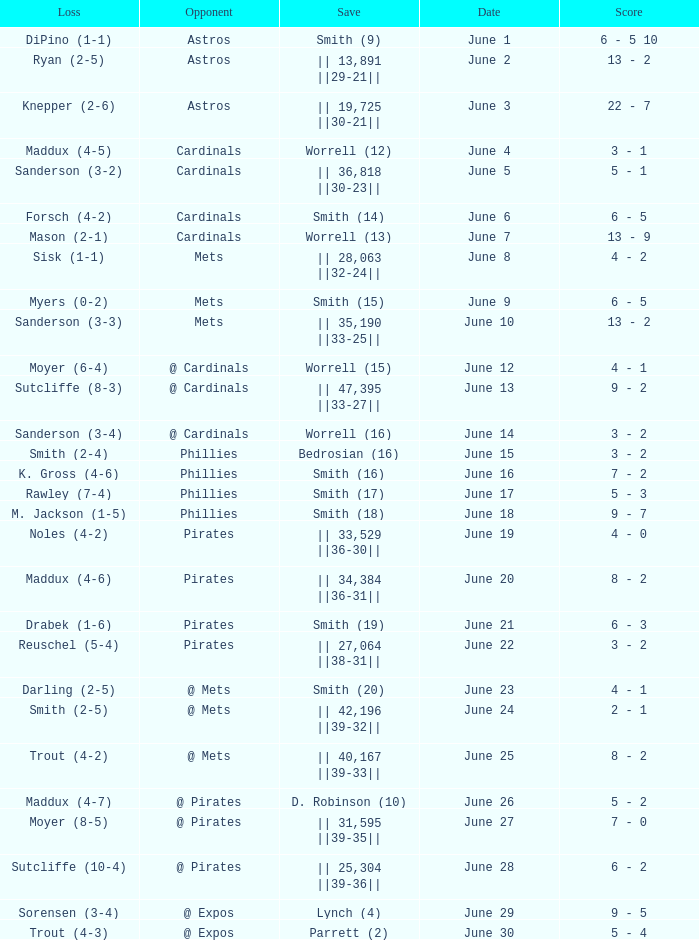What is the date for the game that included a loss of sutcliffe (10-4)? June 28. 